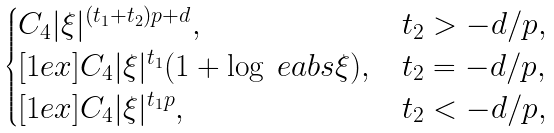<formula> <loc_0><loc_0><loc_500><loc_500>\begin{cases} C _ { 4 } | \xi | ^ { ( t _ { 1 } + t _ { 2 } ) p + d } , & t _ { 2 } > - d / p , \\ [ 1 e x ] C _ { 4 } | \xi | ^ { t _ { 1 } } ( 1 + \log \ e a b s \xi ) , & t _ { 2 } = - d / p , \\ [ 1 e x ] C _ { 4 } | \xi | ^ { t _ { 1 } p } , & t _ { 2 } < - d / p , \end{cases}</formula> 